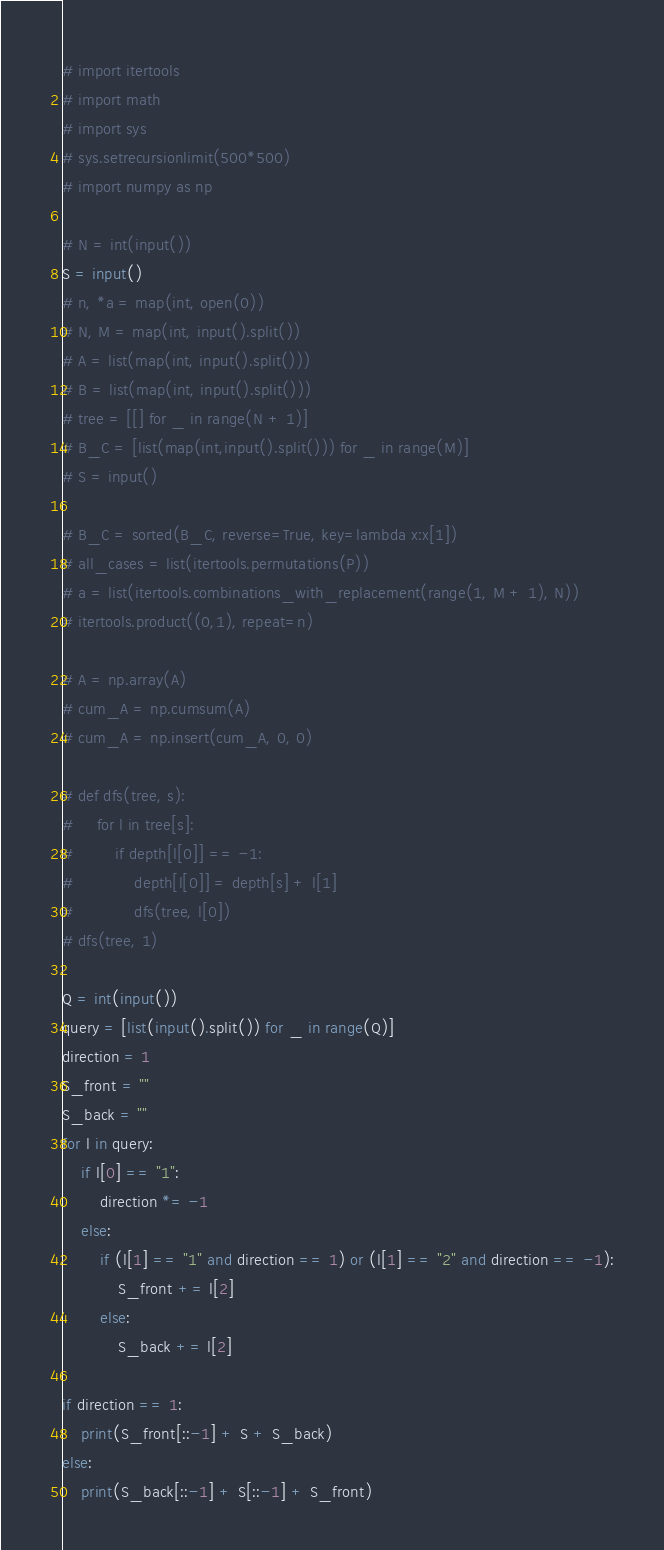Convert code to text. <code><loc_0><loc_0><loc_500><loc_500><_Python_># import itertools
# import math
# import sys
# sys.setrecursionlimit(500*500)
# import numpy as np

# N = int(input())
S = input()
# n, *a = map(int, open(0))
# N, M = map(int, input().split())
# A = list(map(int, input().split()))
# B = list(map(int, input().split()))
# tree = [[] for _ in range(N + 1)]
# B_C = [list(map(int,input().split())) for _ in range(M)]
# S = input()

# B_C = sorted(B_C, reverse=True, key=lambda x:x[1])
# all_cases = list(itertools.permutations(P))
# a = list(itertools.combinations_with_replacement(range(1, M + 1), N))
# itertools.product((0,1), repeat=n)

# A = np.array(A)
# cum_A = np.cumsum(A)
# cum_A = np.insert(cum_A, 0, 0)

# def dfs(tree, s):
#     for l in tree[s]:
#         if depth[l[0]] == -1:
#             depth[l[0]] = depth[s] + l[1]
#             dfs(tree, l[0])
# dfs(tree, 1)

Q = int(input())
query = [list(input().split()) for _ in range(Q)]
direction = 1
S_front = ""
S_back = ""
for l in query:
    if l[0] == "1":
        direction *= -1
    else:
        if (l[1] == "1" and direction == 1) or (l[1] == "2" and direction == -1):
            S_front += l[2]
        else:
            S_back += l[2]

if direction == 1:
    print(S_front[::-1] + S + S_back)
else:
    print(S_back[::-1] + S[::-1] + S_front)</code> 